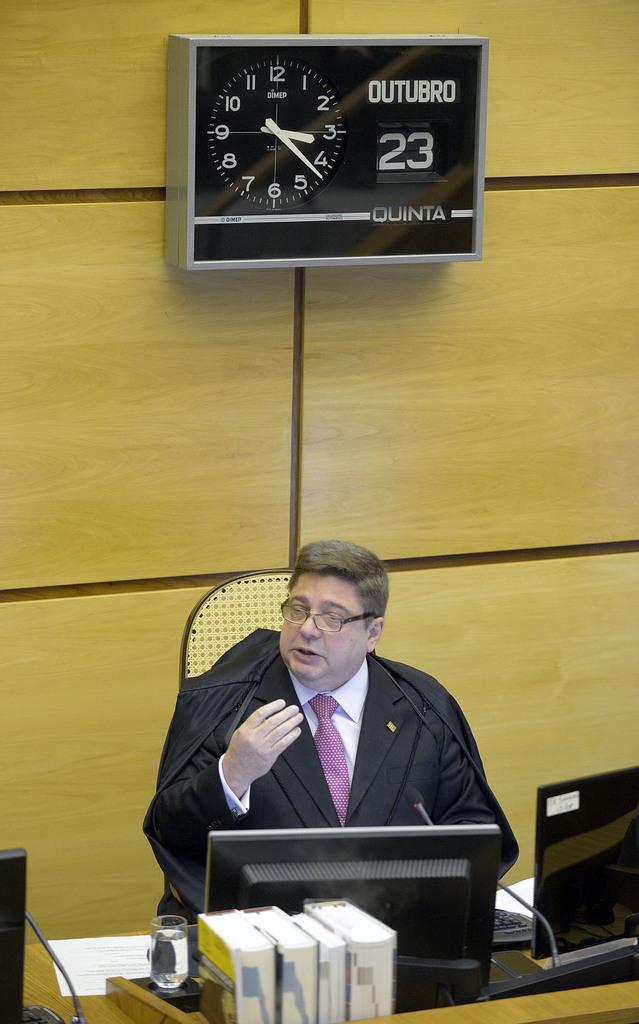What time is it?
Your answer should be very brief. 3:23. 